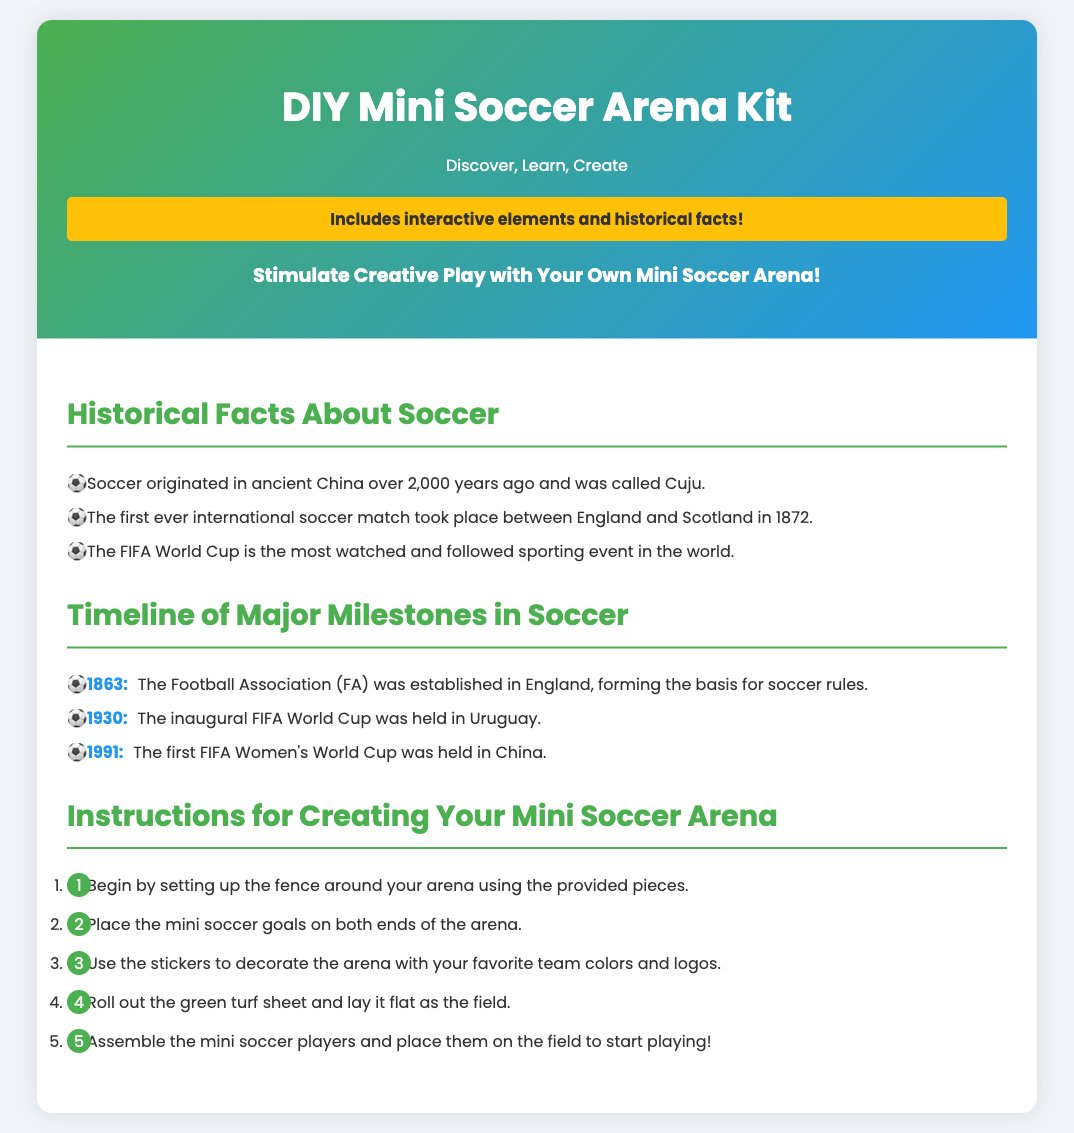What does the kit include? The kit includes interactive elements and historical facts.
Answer: Interactive elements and historical facts When was the first FIFA Women's World Cup held? The document states that the first FIFA Women's World Cup was held in 1991.
Answer: 1991 What is the highlight of the kit? The highlight of the kit is to stimulate creative play with a mini soccer arena.
Answer: Stimulate Creative Play with Your Own Mini Soccer Arena! Who played in the first international soccer match? The document mentions that England and Scotland played in the first international match.
Answer: England and Scotland What year was the Football Association established? Based on the timeline, the Football Association was established in 1863.
Answer: 1863 How many instructions are provided for creating the mini soccer arena? The document lists five steps for creating the mini soccer arena.
Answer: Five steps What is the color of the turf sheet mentioned? The instructions indicate that the turf sheet is green.
Answer: Green In which country was the inaugural FIFA World Cup held? The document states that the inaugural FIFA World Cup was held in Uruguay.
Answer: Uruguay What are the mini soccer goals placed on? According to the instructions, the goals are placed on both ends of the arena.
Answer: Both ends of the arena 